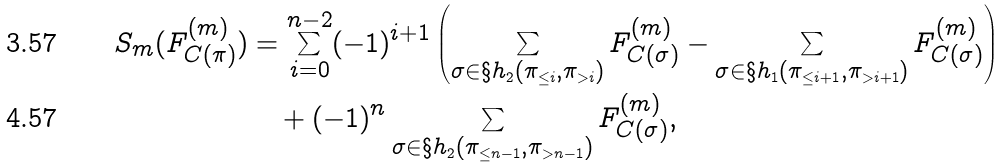<formula> <loc_0><loc_0><loc_500><loc_500>S _ { m } ( F ^ { ( m ) } _ { C ( \pi ) } ) & = \sum _ { i = 0 } ^ { n - 2 } ( - 1 ) ^ { i + 1 } \left ( \sum _ { \sigma \in \S h _ { 2 } ( \pi _ { \leq i } , \pi _ { > i } ) } F ^ { ( m ) } _ { C ( \sigma ) } - \sum _ { \sigma \in \S h _ { 1 } ( \pi _ { \leq i + 1 } , \pi _ { > i + 1 } ) } F ^ { ( m ) } _ { C ( \sigma ) } \right ) \\ & \quad + ( - 1 ) ^ { n } \sum _ { \sigma \in \S h _ { 2 } ( \pi _ { \leq n - 1 } , \pi _ { > n - 1 } ) } F ^ { ( m ) } _ { C ( \sigma ) } ,</formula> 